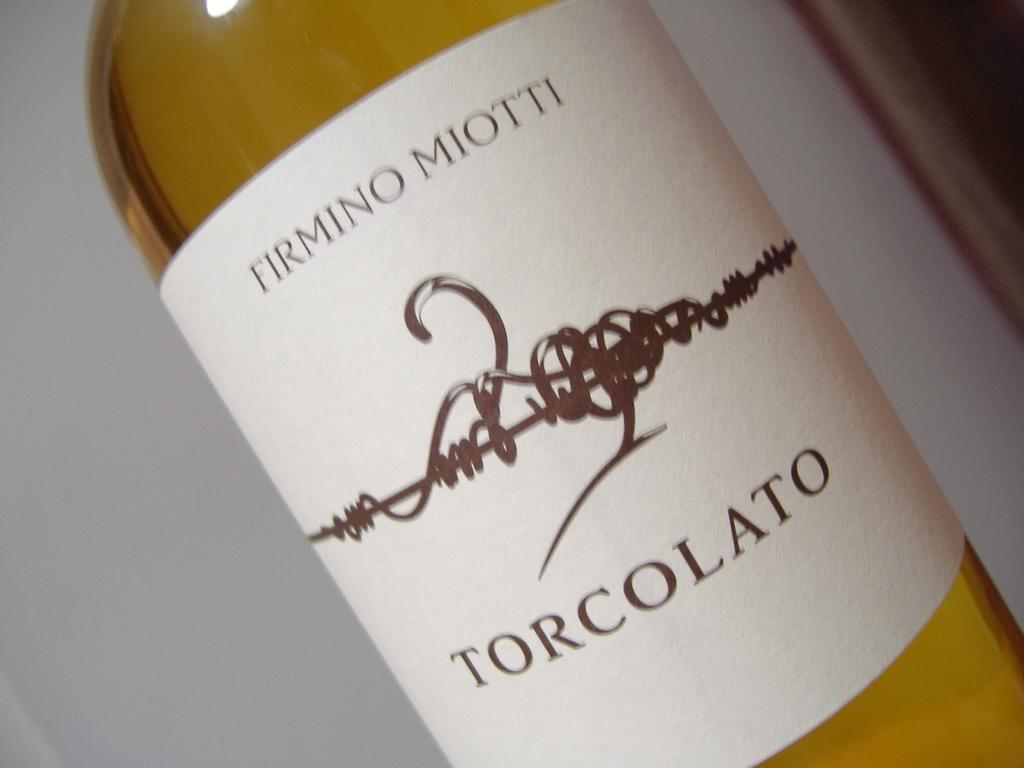<image>
Summarize the visual content of the image. A white bottle label for Firmino Miotti Torcolato. 